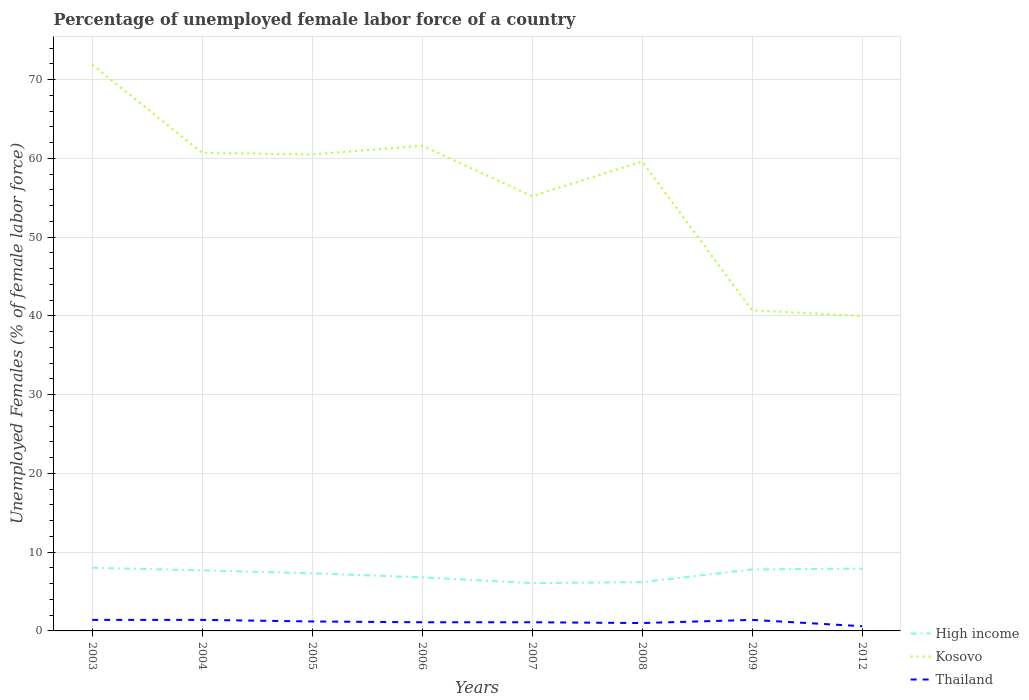Across all years, what is the maximum percentage of unemployed female labor force in High income?
Offer a very short reply. 6.07. What is the total percentage of unemployed female labor force in Thailand in the graph?
Provide a succinct answer. 0. What is the difference between the highest and the second highest percentage of unemployed female labor force in High income?
Provide a short and direct response. 1.95. What is the difference between the highest and the lowest percentage of unemployed female labor force in High income?
Provide a short and direct response. 5. Is the percentage of unemployed female labor force in Thailand strictly greater than the percentage of unemployed female labor force in Kosovo over the years?
Give a very brief answer. Yes. How many lines are there?
Offer a very short reply. 3. What is the difference between two consecutive major ticks on the Y-axis?
Your answer should be very brief. 10. Are the values on the major ticks of Y-axis written in scientific E-notation?
Ensure brevity in your answer.  No. Does the graph contain grids?
Your answer should be very brief. Yes. How are the legend labels stacked?
Provide a short and direct response. Vertical. What is the title of the graph?
Offer a terse response. Percentage of unemployed female labor force of a country. Does "Panama" appear as one of the legend labels in the graph?
Your answer should be compact. No. What is the label or title of the Y-axis?
Ensure brevity in your answer.  Unemployed Females (% of female labor force). What is the Unemployed Females (% of female labor force) in High income in 2003?
Ensure brevity in your answer.  8.02. What is the Unemployed Females (% of female labor force) in Kosovo in 2003?
Ensure brevity in your answer.  71.9. What is the Unemployed Females (% of female labor force) of Thailand in 2003?
Your answer should be compact. 1.4. What is the Unemployed Females (% of female labor force) of High income in 2004?
Provide a short and direct response. 7.69. What is the Unemployed Females (% of female labor force) in Kosovo in 2004?
Your answer should be very brief. 60.7. What is the Unemployed Females (% of female labor force) of Thailand in 2004?
Provide a succinct answer. 1.4. What is the Unemployed Females (% of female labor force) in High income in 2005?
Give a very brief answer. 7.32. What is the Unemployed Females (% of female labor force) of Kosovo in 2005?
Keep it short and to the point. 60.5. What is the Unemployed Females (% of female labor force) in Thailand in 2005?
Your response must be concise. 1.2. What is the Unemployed Females (% of female labor force) in High income in 2006?
Ensure brevity in your answer.  6.8. What is the Unemployed Females (% of female labor force) of Kosovo in 2006?
Give a very brief answer. 61.6. What is the Unemployed Females (% of female labor force) in Thailand in 2006?
Offer a very short reply. 1.1. What is the Unemployed Females (% of female labor force) of High income in 2007?
Make the answer very short. 6.07. What is the Unemployed Females (% of female labor force) in Kosovo in 2007?
Keep it short and to the point. 55.2. What is the Unemployed Females (% of female labor force) of Thailand in 2007?
Your answer should be very brief. 1.1. What is the Unemployed Females (% of female labor force) in High income in 2008?
Make the answer very short. 6.19. What is the Unemployed Females (% of female labor force) in Kosovo in 2008?
Your response must be concise. 59.6. What is the Unemployed Females (% of female labor force) in High income in 2009?
Make the answer very short. 7.81. What is the Unemployed Females (% of female labor force) of Kosovo in 2009?
Ensure brevity in your answer.  40.7. What is the Unemployed Females (% of female labor force) of Thailand in 2009?
Provide a short and direct response. 1.4. What is the Unemployed Females (% of female labor force) in High income in 2012?
Provide a succinct answer. 7.91. What is the Unemployed Females (% of female labor force) of Thailand in 2012?
Offer a terse response. 0.6. Across all years, what is the maximum Unemployed Females (% of female labor force) in High income?
Your answer should be compact. 8.02. Across all years, what is the maximum Unemployed Females (% of female labor force) of Kosovo?
Your answer should be very brief. 71.9. Across all years, what is the maximum Unemployed Females (% of female labor force) of Thailand?
Keep it short and to the point. 1.4. Across all years, what is the minimum Unemployed Females (% of female labor force) of High income?
Provide a succinct answer. 6.07. Across all years, what is the minimum Unemployed Females (% of female labor force) of Thailand?
Provide a short and direct response. 0.6. What is the total Unemployed Females (% of female labor force) of High income in the graph?
Your response must be concise. 57.82. What is the total Unemployed Females (% of female labor force) in Kosovo in the graph?
Offer a terse response. 450.2. What is the difference between the Unemployed Females (% of female labor force) in High income in 2003 and that in 2004?
Your answer should be very brief. 0.33. What is the difference between the Unemployed Females (% of female labor force) in Kosovo in 2003 and that in 2004?
Ensure brevity in your answer.  11.2. What is the difference between the Unemployed Females (% of female labor force) of Thailand in 2003 and that in 2004?
Your answer should be very brief. 0. What is the difference between the Unemployed Females (% of female labor force) in High income in 2003 and that in 2005?
Give a very brief answer. 0.7. What is the difference between the Unemployed Females (% of female labor force) of Kosovo in 2003 and that in 2005?
Provide a succinct answer. 11.4. What is the difference between the Unemployed Females (% of female labor force) in Thailand in 2003 and that in 2005?
Give a very brief answer. 0.2. What is the difference between the Unemployed Females (% of female labor force) of High income in 2003 and that in 2006?
Keep it short and to the point. 1.22. What is the difference between the Unemployed Females (% of female labor force) in High income in 2003 and that in 2007?
Provide a succinct answer. 1.95. What is the difference between the Unemployed Females (% of female labor force) of Thailand in 2003 and that in 2007?
Offer a terse response. 0.3. What is the difference between the Unemployed Females (% of female labor force) in High income in 2003 and that in 2008?
Provide a succinct answer. 1.83. What is the difference between the Unemployed Females (% of female labor force) of Thailand in 2003 and that in 2008?
Your answer should be very brief. 0.4. What is the difference between the Unemployed Females (% of female labor force) of High income in 2003 and that in 2009?
Provide a short and direct response. 0.21. What is the difference between the Unemployed Females (% of female labor force) of Kosovo in 2003 and that in 2009?
Your response must be concise. 31.2. What is the difference between the Unemployed Females (% of female labor force) in Thailand in 2003 and that in 2009?
Ensure brevity in your answer.  0. What is the difference between the Unemployed Females (% of female labor force) in High income in 2003 and that in 2012?
Provide a short and direct response. 0.11. What is the difference between the Unemployed Females (% of female labor force) of Kosovo in 2003 and that in 2012?
Provide a succinct answer. 31.9. What is the difference between the Unemployed Females (% of female labor force) of Thailand in 2003 and that in 2012?
Your answer should be compact. 0.8. What is the difference between the Unemployed Females (% of female labor force) of High income in 2004 and that in 2005?
Keep it short and to the point. 0.37. What is the difference between the Unemployed Females (% of female labor force) in Kosovo in 2004 and that in 2005?
Provide a short and direct response. 0.2. What is the difference between the Unemployed Females (% of female labor force) in High income in 2004 and that in 2006?
Your answer should be compact. 0.89. What is the difference between the Unemployed Females (% of female labor force) of Kosovo in 2004 and that in 2006?
Your answer should be compact. -0.9. What is the difference between the Unemployed Females (% of female labor force) of Thailand in 2004 and that in 2006?
Offer a very short reply. 0.3. What is the difference between the Unemployed Females (% of female labor force) in High income in 2004 and that in 2007?
Give a very brief answer. 1.62. What is the difference between the Unemployed Females (% of female labor force) in High income in 2004 and that in 2008?
Your response must be concise. 1.5. What is the difference between the Unemployed Females (% of female labor force) of High income in 2004 and that in 2009?
Your response must be concise. -0.12. What is the difference between the Unemployed Females (% of female labor force) of High income in 2004 and that in 2012?
Offer a terse response. -0.22. What is the difference between the Unemployed Females (% of female labor force) of Kosovo in 2004 and that in 2012?
Offer a very short reply. 20.7. What is the difference between the Unemployed Females (% of female labor force) in High income in 2005 and that in 2006?
Your answer should be very brief. 0.52. What is the difference between the Unemployed Females (% of female labor force) of Kosovo in 2005 and that in 2006?
Give a very brief answer. -1.1. What is the difference between the Unemployed Females (% of female labor force) in Thailand in 2005 and that in 2006?
Your answer should be compact. 0.1. What is the difference between the Unemployed Females (% of female labor force) in High income in 2005 and that in 2007?
Give a very brief answer. 1.25. What is the difference between the Unemployed Females (% of female labor force) in High income in 2005 and that in 2008?
Provide a short and direct response. 1.13. What is the difference between the Unemployed Females (% of female labor force) in Thailand in 2005 and that in 2008?
Your answer should be compact. 0.2. What is the difference between the Unemployed Females (% of female labor force) in High income in 2005 and that in 2009?
Provide a short and direct response. -0.49. What is the difference between the Unemployed Females (% of female labor force) in Kosovo in 2005 and that in 2009?
Your answer should be very brief. 19.8. What is the difference between the Unemployed Females (% of female labor force) in Thailand in 2005 and that in 2009?
Ensure brevity in your answer.  -0.2. What is the difference between the Unemployed Females (% of female labor force) in High income in 2005 and that in 2012?
Ensure brevity in your answer.  -0.59. What is the difference between the Unemployed Females (% of female labor force) of Kosovo in 2005 and that in 2012?
Provide a short and direct response. 20.5. What is the difference between the Unemployed Females (% of female labor force) in Thailand in 2005 and that in 2012?
Your answer should be compact. 0.6. What is the difference between the Unemployed Females (% of female labor force) in High income in 2006 and that in 2007?
Offer a very short reply. 0.73. What is the difference between the Unemployed Females (% of female labor force) in Kosovo in 2006 and that in 2007?
Ensure brevity in your answer.  6.4. What is the difference between the Unemployed Females (% of female labor force) in High income in 2006 and that in 2008?
Provide a short and direct response. 0.61. What is the difference between the Unemployed Females (% of female labor force) of Kosovo in 2006 and that in 2008?
Your response must be concise. 2. What is the difference between the Unemployed Females (% of female labor force) of High income in 2006 and that in 2009?
Your response must be concise. -1.01. What is the difference between the Unemployed Females (% of female labor force) of Kosovo in 2006 and that in 2009?
Keep it short and to the point. 20.9. What is the difference between the Unemployed Females (% of female labor force) of High income in 2006 and that in 2012?
Your answer should be very brief. -1.11. What is the difference between the Unemployed Females (% of female labor force) of Kosovo in 2006 and that in 2012?
Make the answer very short. 21.6. What is the difference between the Unemployed Females (% of female labor force) in High income in 2007 and that in 2008?
Make the answer very short. -0.12. What is the difference between the Unemployed Females (% of female labor force) in Kosovo in 2007 and that in 2008?
Provide a short and direct response. -4.4. What is the difference between the Unemployed Females (% of female labor force) of Thailand in 2007 and that in 2008?
Your answer should be very brief. 0.1. What is the difference between the Unemployed Females (% of female labor force) of High income in 2007 and that in 2009?
Ensure brevity in your answer.  -1.74. What is the difference between the Unemployed Females (% of female labor force) in High income in 2007 and that in 2012?
Offer a terse response. -1.84. What is the difference between the Unemployed Females (% of female labor force) in High income in 2008 and that in 2009?
Offer a very short reply. -1.62. What is the difference between the Unemployed Females (% of female labor force) in Kosovo in 2008 and that in 2009?
Your answer should be very brief. 18.9. What is the difference between the Unemployed Females (% of female labor force) of Thailand in 2008 and that in 2009?
Make the answer very short. -0.4. What is the difference between the Unemployed Females (% of female labor force) of High income in 2008 and that in 2012?
Your response must be concise. -1.72. What is the difference between the Unemployed Females (% of female labor force) of Kosovo in 2008 and that in 2012?
Provide a short and direct response. 19.6. What is the difference between the Unemployed Females (% of female labor force) in High income in 2009 and that in 2012?
Offer a very short reply. -0.1. What is the difference between the Unemployed Females (% of female labor force) in Thailand in 2009 and that in 2012?
Provide a succinct answer. 0.8. What is the difference between the Unemployed Females (% of female labor force) of High income in 2003 and the Unemployed Females (% of female labor force) of Kosovo in 2004?
Offer a very short reply. -52.68. What is the difference between the Unemployed Females (% of female labor force) of High income in 2003 and the Unemployed Females (% of female labor force) of Thailand in 2004?
Ensure brevity in your answer.  6.62. What is the difference between the Unemployed Females (% of female labor force) in Kosovo in 2003 and the Unemployed Females (% of female labor force) in Thailand in 2004?
Keep it short and to the point. 70.5. What is the difference between the Unemployed Females (% of female labor force) in High income in 2003 and the Unemployed Females (% of female labor force) in Kosovo in 2005?
Ensure brevity in your answer.  -52.48. What is the difference between the Unemployed Females (% of female labor force) of High income in 2003 and the Unemployed Females (% of female labor force) of Thailand in 2005?
Provide a succinct answer. 6.82. What is the difference between the Unemployed Females (% of female labor force) of Kosovo in 2003 and the Unemployed Females (% of female labor force) of Thailand in 2005?
Ensure brevity in your answer.  70.7. What is the difference between the Unemployed Females (% of female labor force) of High income in 2003 and the Unemployed Females (% of female labor force) of Kosovo in 2006?
Your answer should be compact. -53.58. What is the difference between the Unemployed Females (% of female labor force) of High income in 2003 and the Unemployed Females (% of female labor force) of Thailand in 2006?
Offer a terse response. 6.92. What is the difference between the Unemployed Females (% of female labor force) of Kosovo in 2003 and the Unemployed Females (% of female labor force) of Thailand in 2006?
Give a very brief answer. 70.8. What is the difference between the Unemployed Females (% of female labor force) of High income in 2003 and the Unemployed Females (% of female labor force) of Kosovo in 2007?
Your response must be concise. -47.18. What is the difference between the Unemployed Females (% of female labor force) of High income in 2003 and the Unemployed Females (% of female labor force) of Thailand in 2007?
Provide a succinct answer. 6.92. What is the difference between the Unemployed Females (% of female labor force) of Kosovo in 2003 and the Unemployed Females (% of female labor force) of Thailand in 2007?
Offer a terse response. 70.8. What is the difference between the Unemployed Females (% of female labor force) in High income in 2003 and the Unemployed Females (% of female labor force) in Kosovo in 2008?
Provide a short and direct response. -51.58. What is the difference between the Unemployed Females (% of female labor force) in High income in 2003 and the Unemployed Females (% of female labor force) in Thailand in 2008?
Offer a very short reply. 7.02. What is the difference between the Unemployed Females (% of female labor force) of Kosovo in 2003 and the Unemployed Females (% of female labor force) of Thailand in 2008?
Provide a succinct answer. 70.9. What is the difference between the Unemployed Females (% of female labor force) in High income in 2003 and the Unemployed Females (% of female labor force) in Kosovo in 2009?
Your answer should be compact. -32.68. What is the difference between the Unemployed Females (% of female labor force) of High income in 2003 and the Unemployed Females (% of female labor force) of Thailand in 2009?
Keep it short and to the point. 6.62. What is the difference between the Unemployed Females (% of female labor force) in Kosovo in 2003 and the Unemployed Females (% of female labor force) in Thailand in 2009?
Provide a succinct answer. 70.5. What is the difference between the Unemployed Females (% of female labor force) of High income in 2003 and the Unemployed Females (% of female labor force) of Kosovo in 2012?
Offer a very short reply. -31.98. What is the difference between the Unemployed Females (% of female labor force) in High income in 2003 and the Unemployed Females (% of female labor force) in Thailand in 2012?
Provide a succinct answer. 7.42. What is the difference between the Unemployed Females (% of female labor force) in Kosovo in 2003 and the Unemployed Females (% of female labor force) in Thailand in 2012?
Offer a very short reply. 71.3. What is the difference between the Unemployed Females (% of female labor force) of High income in 2004 and the Unemployed Females (% of female labor force) of Kosovo in 2005?
Your answer should be very brief. -52.81. What is the difference between the Unemployed Females (% of female labor force) of High income in 2004 and the Unemployed Females (% of female labor force) of Thailand in 2005?
Offer a terse response. 6.49. What is the difference between the Unemployed Females (% of female labor force) in Kosovo in 2004 and the Unemployed Females (% of female labor force) in Thailand in 2005?
Offer a terse response. 59.5. What is the difference between the Unemployed Females (% of female labor force) of High income in 2004 and the Unemployed Females (% of female labor force) of Kosovo in 2006?
Offer a very short reply. -53.91. What is the difference between the Unemployed Females (% of female labor force) of High income in 2004 and the Unemployed Females (% of female labor force) of Thailand in 2006?
Ensure brevity in your answer.  6.59. What is the difference between the Unemployed Females (% of female labor force) in Kosovo in 2004 and the Unemployed Females (% of female labor force) in Thailand in 2006?
Your answer should be very brief. 59.6. What is the difference between the Unemployed Females (% of female labor force) of High income in 2004 and the Unemployed Females (% of female labor force) of Kosovo in 2007?
Ensure brevity in your answer.  -47.51. What is the difference between the Unemployed Females (% of female labor force) of High income in 2004 and the Unemployed Females (% of female labor force) of Thailand in 2007?
Provide a succinct answer. 6.59. What is the difference between the Unemployed Females (% of female labor force) in Kosovo in 2004 and the Unemployed Females (% of female labor force) in Thailand in 2007?
Keep it short and to the point. 59.6. What is the difference between the Unemployed Females (% of female labor force) of High income in 2004 and the Unemployed Females (% of female labor force) of Kosovo in 2008?
Provide a succinct answer. -51.91. What is the difference between the Unemployed Females (% of female labor force) in High income in 2004 and the Unemployed Females (% of female labor force) in Thailand in 2008?
Offer a very short reply. 6.69. What is the difference between the Unemployed Females (% of female labor force) in Kosovo in 2004 and the Unemployed Females (% of female labor force) in Thailand in 2008?
Ensure brevity in your answer.  59.7. What is the difference between the Unemployed Females (% of female labor force) of High income in 2004 and the Unemployed Females (% of female labor force) of Kosovo in 2009?
Give a very brief answer. -33.01. What is the difference between the Unemployed Females (% of female labor force) of High income in 2004 and the Unemployed Females (% of female labor force) of Thailand in 2009?
Your response must be concise. 6.29. What is the difference between the Unemployed Females (% of female labor force) in Kosovo in 2004 and the Unemployed Females (% of female labor force) in Thailand in 2009?
Give a very brief answer. 59.3. What is the difference between the Unemployed Females (% of female labor force) of High income in 2004 and the Unemployed Females (% of female labor force) of Kosovo in 2012?
Provide a succinct answer. -32.31. What is the difference between the Unemployed Females (% of female labor force) in High income in 2004 and the Unemployed Females (% of female labor force) in Thailand in 2012?
Provide a short and direct response. 7.09. What is the difference between the Unemployed Females (% of female labor force) in Kosovo in 2004 and the Unemployed Females (% of female labor force) in Thailand in 2012?
Keep it short and to the point. 60.1. What is the difference between the Unemployed Females (% of female labor force) in High income in 2005 and the Unemployed Females (% of female labor force) in Kosovo in 2006?
Provide a succinct answer. -54.28. What is the difference between the Unemployed Females (% of female labor force) in High income in 2005 and the Unemployed Females (% of female labor force) in Thailand in 2006?
Your response must be concise. 6.22. What is the difference between the Unemployed Females (% of female labor force) of Kosovo in 2005 and the Unemployed Females (% of female labor force) of Thailand in 2006?
Your response must be concise. 59.4. What is the difference between the Unemployed Females (% of female labor force) of High income in 2005 and the Unemployed Females (% of female labor force) of Kosovo in 2007?
Your response must be concise. -47.88. What is the difference between the Unemployed Females (% of female labor force) of High income in 2005 and the Unemployed Females (% of female labor force) of Thailand in 2007?
Your response must be concise. 6.22. What is the difference between the Unemployed Females (% of female labor force) in Kosovo in 2005 and the Unemployed Females (% of female labor force) in Thailand in 2007?
Your response must be concise. 59.4. What is the difference between the Unemployed Females (% of female labor force) in High income in 2005 and the Unemployed Females (% of female labor force) in Kosovo in 2008?
Offer a terse response. -52.28. What is the difference between the Unemployed Females (% of female labor force) in High income in 2005 and the Unemployed Females (% of female labor force) in Thailand in 2008?
Make the answer very short. 6.32. What is the difference between the Unemployed Females (% of female labor force) of Kosovo in 2005 and the Unemployed Females (% of female labor force) of Thailand in 2008?
Provide a succinct answer. 59.5. What is the difference between the Unemployed Females (% of female labor force) in High income in 2005 and the Unemployed Females (% of female labor force) in Kosovo in 2009?
Your answer should be compact. -33.38. What is the difference between the Unemployed Females (% of female labor force) in High income in 2005 and the Unemployed Females (% of female labor force) in Thailand in 2009?
Give a very brief answer. 5.92. What is the difference between the Unemployed Females (% of female labor force) of Kosovo in 2005 and the Unemployed Females (% of female labor force) of Thailand in 2009?
Offer a very short reply. 59.1. What is the difference between the Unemployed Females (% of female labor force) of High income in 2005 and the Unemployed Females (% of female labor force) of Kosovo in 2012?
Offer a terse response. -32.68. What is the difference between the Unemployed Females (% of female labor force) of High income in 2005 and the Unemployed Females (% of female labor force) of Thailand in 2012?
Your response must be concise. 6.72. What is the difference between the Unemployed Females (% of female labor force) in Kosovo in 2005 and the Unemployed Females (% of female labor force) in Thailand in 2012?
Ensure brevity in your answer.  59.9. What is the difference between the Unemployed Females (% of female labor force) in High income in 2006 and the Unemployed Females (% of female labor force) in Kosovo in 2007?
Your response must be concise. -48.4. What is the difference between the Unemployed Females (% of female labor force) in High income in 2006 and the Unemployed Females (% of female labor force) in Thailand in 2007?
Give a very brief answer. 5.7. What is the difference between the Unemployed Females (% of female labor force) of Kosovo in 2006 and the Unemployed Females (% of female labor force) of Thailand in 2007?
Give a very brief answer. 60.5. What is the difference between the Unemployed Females (% of female labor force) in High income in 2006 and the Unemployed Females (% of female labor force) in Kosovo in 2008?
Give a very brief answer. -52.8. What is the difference between the Unemployed Females (% of female labor force) in High income in 2006 and the Unemployed Females (% of female labor force) in Thailand in 2008?
Offer a very short reply. 5.8. What is the difference between the Unemployed Females (% of female labor force) of Kosovo in 2006 and the Unemployed Females (% of female labor force) of Thailand in 2008?
Offer a terse response. 60.6. What is the difference between the Unemployed Females (% of female labor force) in High income in 2006 and the Unemployed Females (% of female labor force) in Kosovo in 2009?
Keep it short and to the point. -33.9. What is the difference between the Unemployed Females (% of female labor force) in High income in 2006 and the Unemployed Females (% of female labor force) in Thailand in 2009?
Your response must be concise. 5.4. What is the difference between the Unemployed Females (% of female labor force) of Kosovo in 2006 and the Unemployed Females (% of female labor force) of Thailand in 2009?
Keep it short and to the point. 60.2. What is the difference between the Unemployed Females (% of female labor force) in High income in 2006 and the Unemployed Females (% of female labor force) in Kosovo in 2012?
Your response must be concise. -33.2. What is the difference between the Unemployed Females (% of female labor force) in High income in 2006 and the Unemployed Females (% of female labor force) in Thailand in 2012?
Give a very brief answer. 6.2. What is the difference between the Unemployed Females (% of female labor force) in Kosovo in 2006 and the Unemployed Females (% of female labor force) in Thailand in 2012?
Your answer should be compact. 61. What is the difference between the Unemployed Females (% of female labor force) in High income in 2007 and the Unemployed Females (% of female labor force) in Kosovo in 2008?
Your answer should be very brief. -53.53. What is the difference between the Unemployed Females (% of female labor force) of High income in 2007 and the Unemployed Females (% of female labor force) of Thailand in 2008?
Offer a terse response. 5.07. What is the difference between the Unemployed Females (% of female labor force) in Kosovo in 2007 and the Unemployed Females (% of female labor force) in Thailand in 2008?
Your answer should be very brief. 54.2. What is the difference between the Unemployed Females (% of female labor force) of High income in 2007 and the Unemployed Females (% of female labor force) of Kosovo in 2009?
Your answer should be very brief. -34.63. What is the difference between the Unemployed Females (% of female labor force) in High income in 2007 and the Unemployed Females (% of female labor force) in Thailand in 2009?
Offer a very short reply. 4.67. What is the difference between the Unemployed Females (% of female labor force) in Kosovo in 2007 and the Unemployed Females (% of female labor force) in Thailand in 2009?
Make the answer very short. 53.8. What is the difference between the Unemployed Females (% of female labor force) in High income in 2007 and the Unemployed Females (% of female labor force) in Kosovo in 2012?
Offer a terse response. -33.93. What is the difference between the Unemployed Females (% of female labor force) of High income in 2007 and the Unemployed Females (% of female labor force) of Thailand in 2012?
Keep it short and to the point. 5.47. What is the difference between the Unemployed Females (% of female labor force) in Kosovo in 2007 and the Unemployed Females (% of female labor force) in Thailand in 2012?
Provide a succinct answer. 54.6. What is the difference between the Unemployed Females (% of female labor force) of High income in 2008 and the Unemployed Females (% of female labor force) of Kosovo in 2009?
Offer a terse response. -34.51. What is the difference between the Unemployed Females (% of female labor force) in High income in 2008 and the Unemployed Females (% of female labor force) in Thailand in 2009?
Keep it short and to the point. 4.79. What is the difference between the Unemployed Females (% of female labor force) of Kosovo in 2008 and the Unemployed Females (% of female labor force) of Thailand in 2009?
Make the answer very short. 58.2. What is the difference between the Unemployed Females (% of female labor force) in High income in 2008 and the Unemployed Females (% of female labor force) in Kosovo in 2012?
Offer a terse response. -33.81. What is the difference between the Unemployed Females (% of female labor force) in High income in 2008 and the Unemployed Females (% of female labor force) in Thailand in 2012?
Your response must be concise. 5.59. What is the difference between the Unemployed Females (% of female labor force) of High income in 2009 and the Unemployed Females (% of female labor force) of Kosovo in 2012?
Offer a very short reply. -32.19. What is the difference between the Unemployed Females (% of female labor force) of High income in 2009 and the Unemployed Females (% of female labor force) of Thailand in 2012?
Provide a succinct answer. 7.21. What is the difference between the Unemployed Females (% of female labor force) of Kosovo in 2009 and the Unemployed Females (% of female labor force) of Thailand in 2012?
Give a very brief answer. 40.1. What is the average Unemployed Females (% of female labor force) of High income per year?
Provide a short and direct response. 7.23. What is the average Unemployed Females (% of female labor force) of Kosovo per year?
Make the answer very short. 56.27. What is the average Unemployed Females (% of female labor force) of Thailand per year?
Keep it short and to the point. 1.15. In the year 2003, what is the difference between the Unemployed Females (% of female labor force) of High income and Unemployed Females (% of female labor force) of Kosovo?
Make the answer very short. -63.88. In the year 2003, what is the difference between the Unemployed Females (% of female labor force) of High income and Unemployed Females (% of female labor force) of Thailand?
Provide a succinct answer. 6.62. In the year 2003, what is the difference between the Unemployed Females (% of female labor force) in Kosovo and Unemployed Females (% of female labor force) in Thailand?
Ensure brevity in your answer.  70.5. In the year 2004, what is the difference between the Unemployed Females (% of female labor force) of High income and Unemployed Females (% of female labor force) of Kosovo?
Provide a short and direct response. -53.01. In the year 2004, what is the difference between the Unemployed Females (% of female labor force) in High income and Unemployed Females (% of female labor force) in Thailand?
Provide a short and direct response. 6.29. In the year 2004, what is the difference between the Unemployed Females (% of female labor force) of Kosovo and Unemployed Females (% of female labor force) of Thailand?
Your answer should be compact. 59.3. In the year 2005, what is the difference between the Unemployed Females (% of female labor force) of High income and Unemployed Females (% of female labor force) of Kosovo?
Ensure brevity in your answer.  -53.18. In the year 2005, what is the difference between the Unemployed Females (% of female labor force) of High income and Unemployed Females (% of female labor force) of Thailand?
Your answer should be compact. 6.12. In the year 2005, what is the difference between the Unemployed Females (% of female labor force) in Kosovo and Unemployed Females (% of female labor force) in Thailand?
Your answer should be very brief. 59.3. In the year 2006, what is the difference between the Unemployed Females (% of female labor force) of High income and Unemployed Females (% of female labor force) of Kosovo?
Provide a succinct answer. -54.8. In the year 2006, what is the difference between the Unemployed Females (% of female labor force) of High income and Unemployed Females (% of female labor force) of Thailand?
Your answer should be very brief. 5.7. In the year 2006, what is the difference between the Unemployed Females (% of female labor force) in Kosovo and Unemployed Females (% of female labor force) in Thailand?
Provide a short and direct response. 60.5. In the year 2007, what is the difference between the Unemployed Females (% of female labor force) in High income and Unemployed Females (% of female labor force) in Kosovo?
Ensure brevity in your answer.  -49.13. In the year 2007, what is the difference between the Unemployed Females (% of female labor force) of High income and Unemployed Females (% of female labor force) of Thailand?
Offer a very short reply. 4.97. In the year 2007, what is the difference between the Unemployed Females (% of female labor force) of Kosovo and Unemployed Females (% of female labor force) of Thailand?
Give a very brief answer. 54.1. In the year 2008, what is the difference between the Unemployed Females (% of female labor force) of High income and Unemployed Females (% of female labor force) of Kosovo?
Provide a succinct answer. -53.41. In the year 2008, what is the difference between the Unemployed Females (% of female labor force) of High income and Unemployed Females (% of female labor force) of Thailand?
Provide a short and direct response. 5.19. In the year 2008, what is the difference between the Unemployed Females (% of female labor force) in Kosovo and Unemployed Females (% of female labor force) in Thailand?
Your answer should be very brief. 58.6. In the year 2009, what is the difference between the Unemployed Females (% of female labor force) of High income and Unemployed Females (% of female labor force) of Kosovo?
Give a very brief answer. -32.89. In the year 2009, what is the difference between the Unemployed Females (% of female labor force) of High income and Unemployed Females (% of female labor force) of Thailand?
Give a very brief answer. 6.41. In the year 2009, what is the difference between the Unemployed Females (% of female labor force) of Kosovo and Unemployed Females (% of female labor force) of Thailand?
Offer a very short reply. 39.3. In the year 2012, what is the difference between the Unemployed Females (% of female labor force) in High income and Unemployed Females (% of female labor force) in Kosovo?
Offer a terse response. -32.09. In the year 2012, what is the difference between the Unemployed Females (% of female labor force) in High income and Unemployed Females (% of female labor force) in Thailand?
Keep it short and to the point. 7.31. In the year 2012, what is the difference between the Unemployed Females (% of female labor force) in Kosovo and Unemployed Females (% of female labor force) in Thailand?
Offer a terse response. 39.4. What is the ratio of the Unemployed Females (% of female labor force) in High income in 2003 to that in 2004?
Give a very brief answer. 1.04. What is the ratio of the Unemployed Females (% of female labor force) in Kosovo in 2003 to that in 2004?
Your answer should be compact. 1.18. What is the ratio of the Unemployed Females (% of female labor force) of High income in 2003 to that in 2005?
Offer a very short reply. 1.1. What is the ratio of the Unemployed Females (% of female labor force) of Kosovo in 2003 to that in 2005?
Ensure brevity in your answer.  1.19. What is the ratio of the Unemployed Females (% of female labor force) of Thailand in 2003 to that in 2005?
Your response must be concise. 1.17. What is the ratio of the Unemployed Females (% of female labor force) in High income in 2003 to that in 2006?
Your response must be concise. 1.18. What is the ratio of the Unemployed Females (% of female labor force) of Kosovo in 2003 to that in 2006?
Provide a succinct answer. 1.17. What is the ratio of the Unemployed Females (% of female labor force) of Thailand in 2003 to that in 2006?
Your answer should be compact. 1.27. What is the ratio of the Unemployed Females (% of female labor force) in High income in 2003 to that in 2007?
Offer a very short reply. 1.32. What is the ratio of the Unemployed Females (% of female labor force) in Kosovo in 2003 to that in 2007?
Your response must be concise. 1.3. What is the ratio of the Unemployed Females (% of female labor force) in Thailand in 2003 to that in 2007?
Ensure brevity in your answer.  1.27. What is the ratio of the Unemployed Females (% of female labor force) of High income in 2003 to that in 2008?
Your answer should be very brief. 1.3. What is the ratio of the Unemployed Females (% of female labor force) of Kosovo in 2003 to that in 2008?
Provide a short and direct response. 1.21. What is the ratio of the Unemployed Females (% of female labor force) in High income in 2003 to that in 2009?
Keep it short and to the point. 1.03. What is the ratio of the Unemployed Females (% of female labor force) of Kosovo in 2003 to that in 2009?
Your answer should be compact. 1.77. What is the ratio of the Unemployed Females (% of female labor force) in High income in 2003 to that in 2012?
Provide a short and direct response. 1.01. What is the ratio of the Unemployed Females (% of female labor force) in Kosovo in 2003 to that in 2012?
Provide a short and direct response. 1.8. What is the ratio of the Unemployed Females (% of female labor force) of Thailand in 2003 to that in 2012?
Your answer should be compact. 2.33. What is the ratio of the Unemployed Females (% of female labor force) in High income in 2004 to that in 2005?
Provide a succinct answer. 1.05. What is the ratio of the Unemployed Females (% of female labor force) in Kosovo in 2004 to that in 2005?
Offer a very short reply. 1. What is the ratio of the Unemployed Females (% of female labor force) of Thailand in 2004 to that in 2005?
Provide a short and direct response. 1.17. What is the ratio of the Unemployed Females (% of female labor force) in High income in 2004 to that in 2006?
Offer a very short reply. 1.13. What is the ratio of the Unemployed Females (% of female labor force) of Kosovo in 2004 to that in 2006?
Make the answer very short. 0.99. What is the ratio of the Unemployed Females (% of female labor force) of Thailand in 2004 to that in 2006?
Give a very brief answer. 1.27. What is the ratio of the Unemployed Females (% of female labor force) in High income in 2004 to that in 2007?
Provide a succinct answer. 1.27. What is the ratio of the Unemployed Females (% of female labor force) in Kosovo in 2004 to that in 2007?
Offer a terse response. 1.1. What is the ratio of the Unemployed Females (% of female labor force) in Thailand in 2004 to that in 2007?
Give a very brief answer. 1.27. What is the ratio of the Unemployed Females (% of female labor force) in High income in 2004 to that in 2008?
Your answer should be very brief. 1.24. What is the ratio of the Unemployed Females (% of female labor force) of Kosovo in 2004 to that in 2008?
Make the answer very short. 1.02. What is the ratio of the Unemployed Females (% of female labor force) of Thailand in 2004 to that in 2008?
Offer a terse response. 1.4. What is the ratio of the Unemployed Females (% of female labor force) in High income in 2004 to that in 2009?
Your answer should be compact. 0.98. What is the ratio of the Unemployed Females (% of female labor force) in Kosovo in 2004 to that in 2009?
Provide a short and direct response. 1.49. What is the ratio of the Unemployed Females (% of female labor force) in High income in 2004 to that in 2012?
Ensure brevity in your answer.  0.97. What is the ratio of the Unemployed Females (% of female labor force) in Kosovo in 2004 to that in 2012?
Offer a terse response. 1.52. What is the ratio of the Unemployed Females (% of female labor force) of Thailand in 2004 to that in 2012?
Your answer should be compact. 2.33. What is the ratio of the Unemployed Females (% of female labor force) of High income in 2005 to that in 2006?
Your answer should be compact. 1.08. What is the ratio of the Unemployed Females (% of female labor force) of Kosovo in 2005 to that in 2006?
Give a very brief answer. 0.98. What is the ratio of the Unemployed Females (% of female labor force) in Thailand in 2005 to that in 2006?
Offer a very short reply. 1.09. What is the ratio of the Unemployed Females (% of female labor force) of High income in 2005 to that in 2007?
Ensure brevity in your answer.  1.21. What is the ratio of the Unemployed Females (% of female labor force) in Kosovo in 2005 to that in 2007?
Your answer should be compact. 1.1. What is the ratio of the Unemployed Females (% of female labor force) of Thailand in 2005 to that in 2007?
Keep it short and to the point. 1.09. What is the ratio of the Unemployed Females (% of female labor force) of High income in 2005 to that in 2008?
Your answer should be very brief. 1.18. What is the ratio of the Unemployed Females (% of female labor force) of Kosovo in 2005 to that in 2008?
Keep it short and to the point. 1.02. What is the ratio of the Unemployed Females (% of female labor force) in Thailand in 2005 to that in 2008?
Offer a very short reply. 1.2. What is the ratio of the Unemployed Females (% of female labor force) in High income in 2005 to that in 2009?
Offer a terse response. 0.94. What is the ratio of the Unemployed Females (% of female labor force) of Kosovo in 2005 to that in 2009?
Give a very brief answer. 1.49. What is the ratio of the Unemployed Females (% of female labor force) of Thailand in 2005 to that in 2009?
Offer a very short reply. 0.86. What is the ratio of the Unemployed Females (% of female labor force) in High income in 2005 to that in 2012?
Offer a very short reply. 0.93. What is the ratio of the Unemployed Females (% of female labor force) of Kosovo in 2005 to that in 2012?
Your response must be concise. 1.51. What is the ratio of the Unemployed Females (% of female labor force) in High income in 2006 to that in 2007?
Make the answer very short. 1.12. What is the ratio of the Unemployed Females (% of female labor force) of Kosovo in 2006 to that in 2007?
Keep it short and to the point. 1.12. What is the ratio of the Unemployed Females (% of female labor force) in High income in 2006 to that in 2008?
Ensure brevity in your answer.  1.1. What is the ratio of the Unemployed Females (% of female labor force) of Kosovo in 2006 to that in 2008?
Offer a very short reply. 1.03. What is the ratio of the Unemployed Females (% of female labor force) of High income in 2006 to that in 2009?
Give a very brief answer. 0.87. What is the ratio of the Unemployed Females (% of female labor force) of Kosovo in 2006 to that in 2009?
Provide a succinct answer. 1.51. What is the ratio of the Unemployed Females (% of female labor force) of Thailand in 2006 to that in 2009?
Offer a terse response. 0.79. What is the ratio of the Unemployed Females (% of female labor force) of High income in 2006 to that in 2012?
Give a very brief answer. 0.86. What is the ratio of the Unemployed Females (% of female labor force) of Kosovo in 2006 to that in 2012?
Offer a very short reply. 1.54. What is the ratio of the Unemployed Females (% of female labor force) in Thailand in 2006 to that in 2012?
Offer a very short reply. 1.83. What is the ratio of the Unemployed Females (% of female labor force) in High income in 2007 to that in 2008?
Provide a succinct answer. 0.98. What is the ratio of the Unemployed Females (% of female labor force) of Kosovo in 2007 to that in 2008?
Your answer should be very brief. 0.93. What is the ratio of the Unemployed Females (% of female labor force) of Thailand in 2007 to that in 2008?
Make the answer very short. 1.1. What is the ratio of the Unemployed Females (% of female labor force) in High income in 2007 to that in 2009?
Make the answer very short. 0.78. What is the ratio of the Unemployed Females (% of female labor force) in Kosovo in 2007 to that in 2009?
Offer a terse response. 1.36. What is the ratio of the Unemployed Females (% of female labor force) in Thailand in 2007 to that in 2009?
Offer a terse response. 0.79. What is the ratio of the Unemployed Females (% of female labor force) of High income in 2007 to that in 2012?
Keep it short and to the point. 0.77. What is the ratio of the Unemployed Females (% of female labor force) of Kosovo in 2007 to that in 2012?
Provide a short and direct response. 1.38. What is the ratio of the Unemployed Females (% of female labor force) in Thailand in 2007 to that in 2012?
Your response must be concise. 1.83. What is the ratio of the Unemployed Females (% of female labor force) of High income in 2008 to that in 2009?
Your answer should be compact. 0.79. What is the ratio of the Unemployed Females (% of female labor force) of Kosovo in 2008 to that in 2009?
Offer a very short reply. 1.46. What is the ratio of the Unemployed Females (% of female labor force) in High income in 2008 to that in 2012?
Give a very brief answer. 0.78. What is the ratio of the Unemployed Females (% of female labor force) of Kosovo in 2008 to that in 2012?
Keep it short and to the point. 1.49. What is the ratio of the Unemployed Females (% of female labor force) of High income in 2009 to that in 2012?
Your response must be concise. 0.99. What is the ratio of the Unemployed Females (% of female labor force) in Kosovo in 2009 to that in 2012?
Your answer should be compact. 1.02. What is the ratio of the Unemployed Females (% of female labor force) of Thailand in 2009 to that in 2012?
Make the answer very short. 2.33. What is the difference between the highest and the second highest Unemployed Females (% of female labor force) of High income?
Keep it short and to the point. 0.11. What is the difference between the highest and the lowest Unemployed Females (% of female labor force) in High income?
Your answer should be compact. 1.95. What is the difference between the highest and the lowest Unemployed Females (% of female labor force) of Kosovo?
Your answer should be compact. 31.9. What is the difference between the highest and the lowest Unemployed Females (% of female labor force) in Thailand?
Provide a succinct answer. 0.8. 